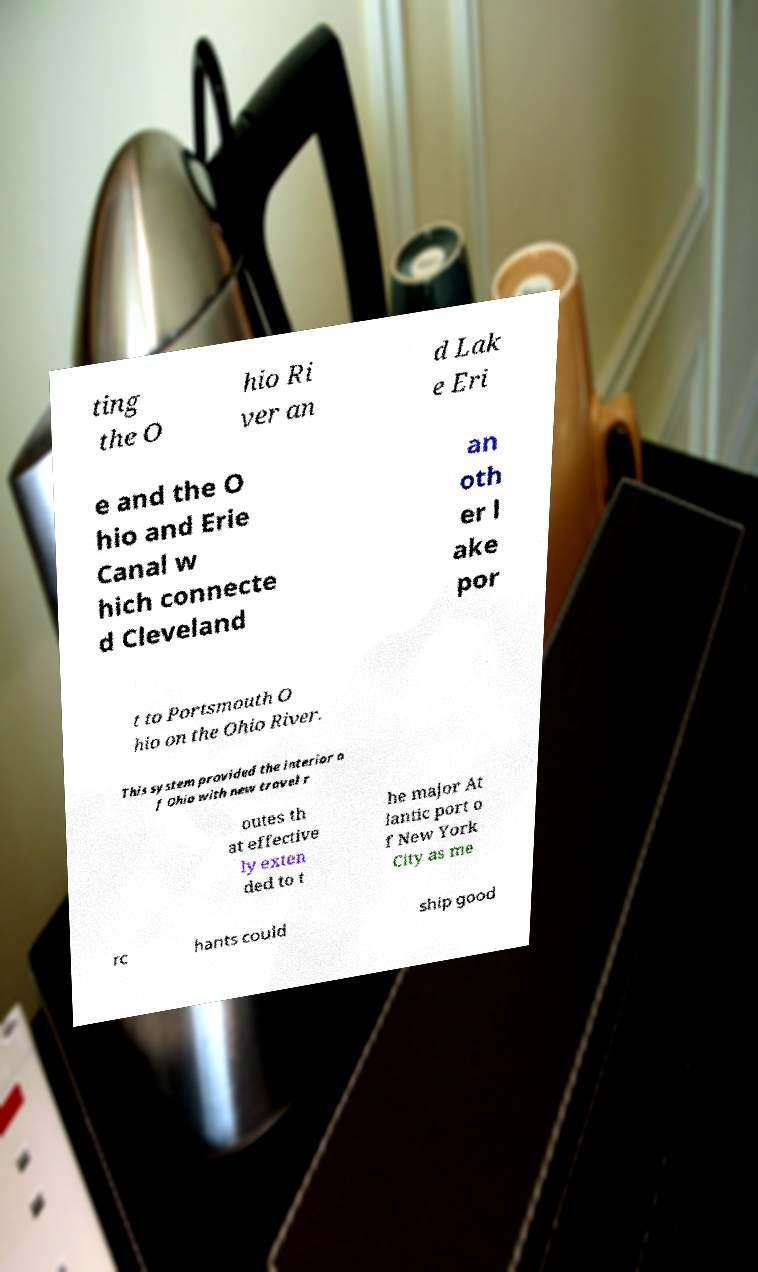What messages or text are displayed in this image? I need them in a readable, typed format. ting the O hio Ri ver an d Lak e Eri e and the O hio and Erie Canal w hich connecte d Cleveland an oth er l ake por t to Portsmouth O hio on the Ohio River. This system provided the interior o f Ohio with new travel r outes th at effective ly exten ded to t he major At lantic port o f New York City as me rc hants could ship good 